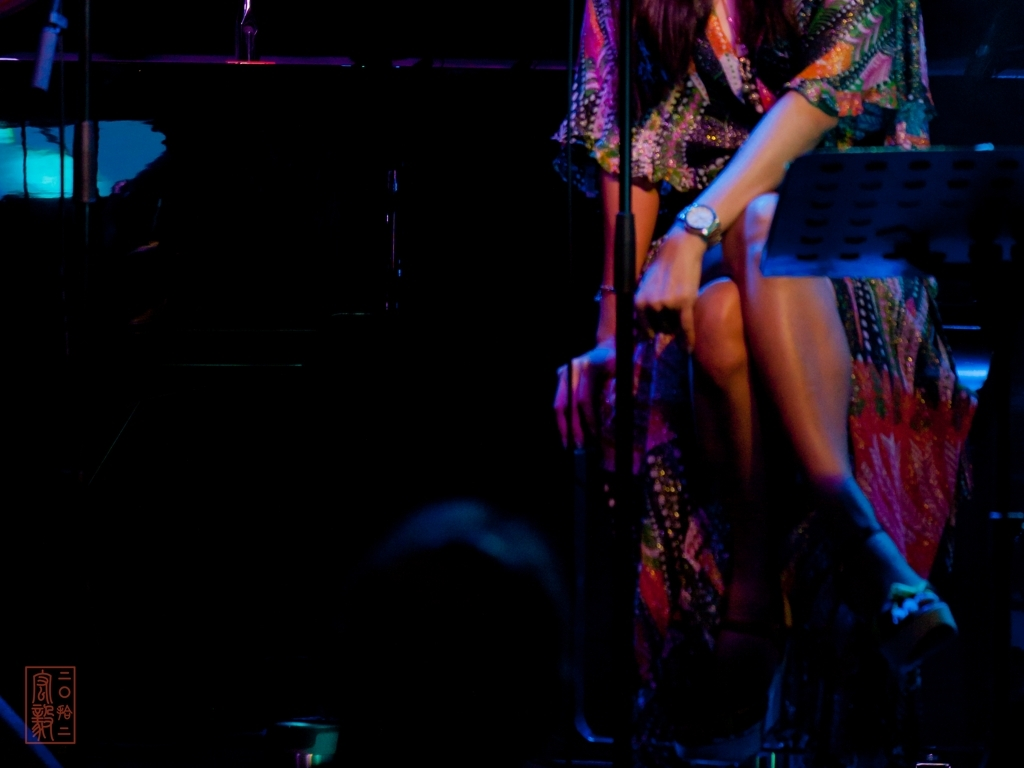Can you describe the atmosphere suggested by the lighting in this image? The image suggests an atmospheric setting with ambient, low-key lighting that is likely designed to focus the audience's attention on the performer, enhance the emotional experience, and provide a cozy, personal ambiance. 